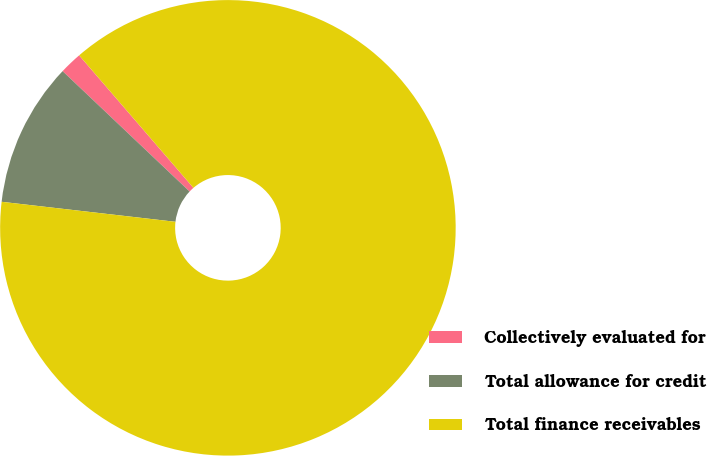Convert chart. <chart><loc_0><loc_0><loc_500><loc_500><pie_chart><fcel>Collectively evaluated for<fcel>Total allowance for credit<fcel>Total finance receivables<nl><fcel>1.6%<fcel>10.25%<fcel>88.15%<nl></chart> 